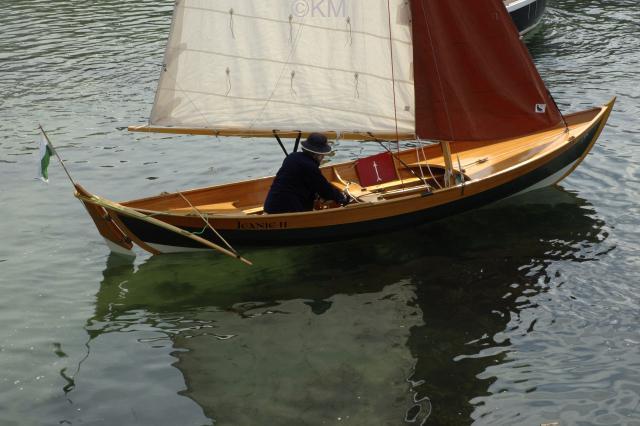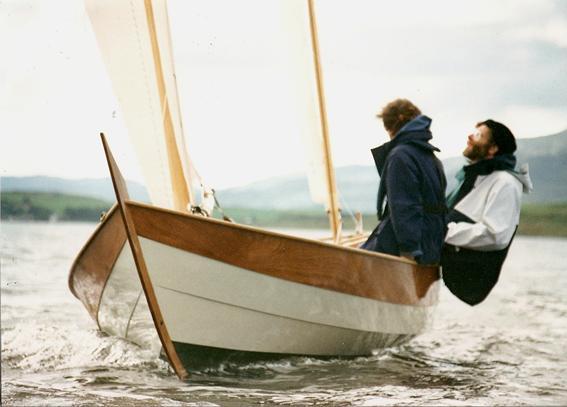The first image is the image on the left, the second image is the image on the right. Evaluate the accuracy of this statement regarding the images: "One person is in a sailboat in the image on the left.". Is it true? Answer yes or no. Yes. The first image is the image on the left, the second image is the image on the right. Evaluate the accuracy of this statement regarding the images: "The left image shows exactly one boat, which has an upright sail and one rider inside.". Is it true? Answer yes or no. Yes. 